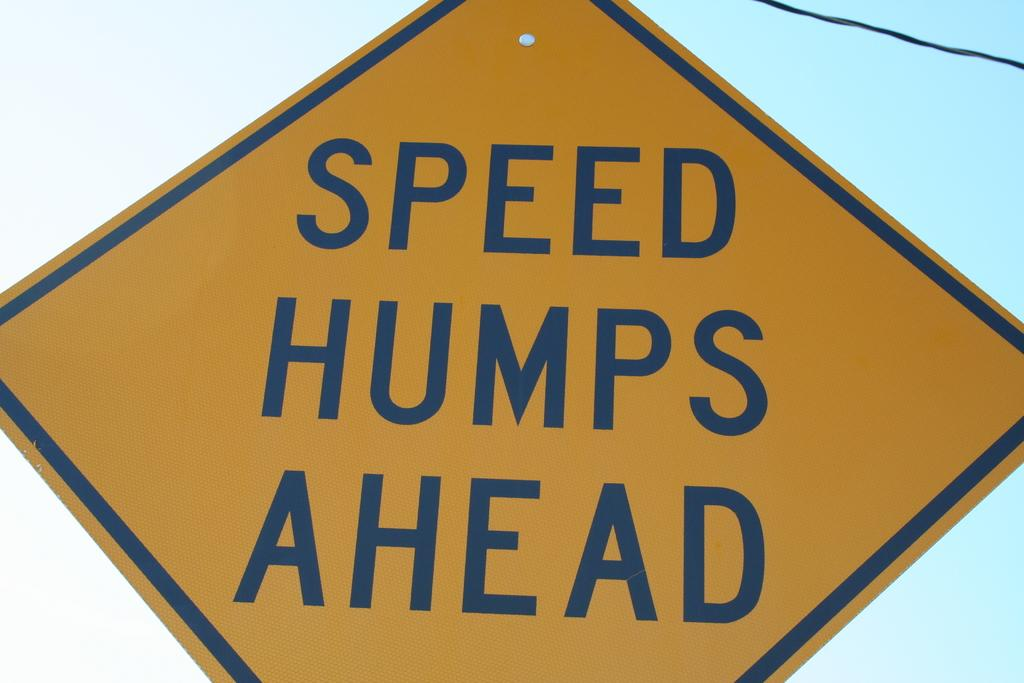<image>
Describe the image concisely. A yellow sign warns that there are speed humps ahead. 